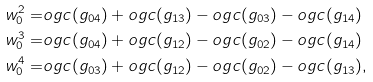<formula> <loc_0><loc_0><loc_500><loc_500>w _ { 0 } ^ { 2 } = & \L o g c ( g _ { 0 4 } ) + \L o g c ( g _ { 1 3 } ) - \L o g c ( g _ { 0 3 } ) - \L o g c ( g _ { 1 4 } ) \\ w _ { 0 } ^ { 3 } = & \L o g c ( g _ { 0 4 } ) + \L o g c ( g _ { 1 2 } ) - \L o g c ( g _ { 0 2 } ) - \L o g c ( g _ { 1 4 } ) \\ w _ { 0 } ^ { 4 } = & \L o g c ( g _ { 0 3 } ) + \L o g c ( g _ { 1 2 } ) - \L o g c ( g _ { 0 2 } ) - \L o g c ( g _ { 1 3 } ) ,</formula> 